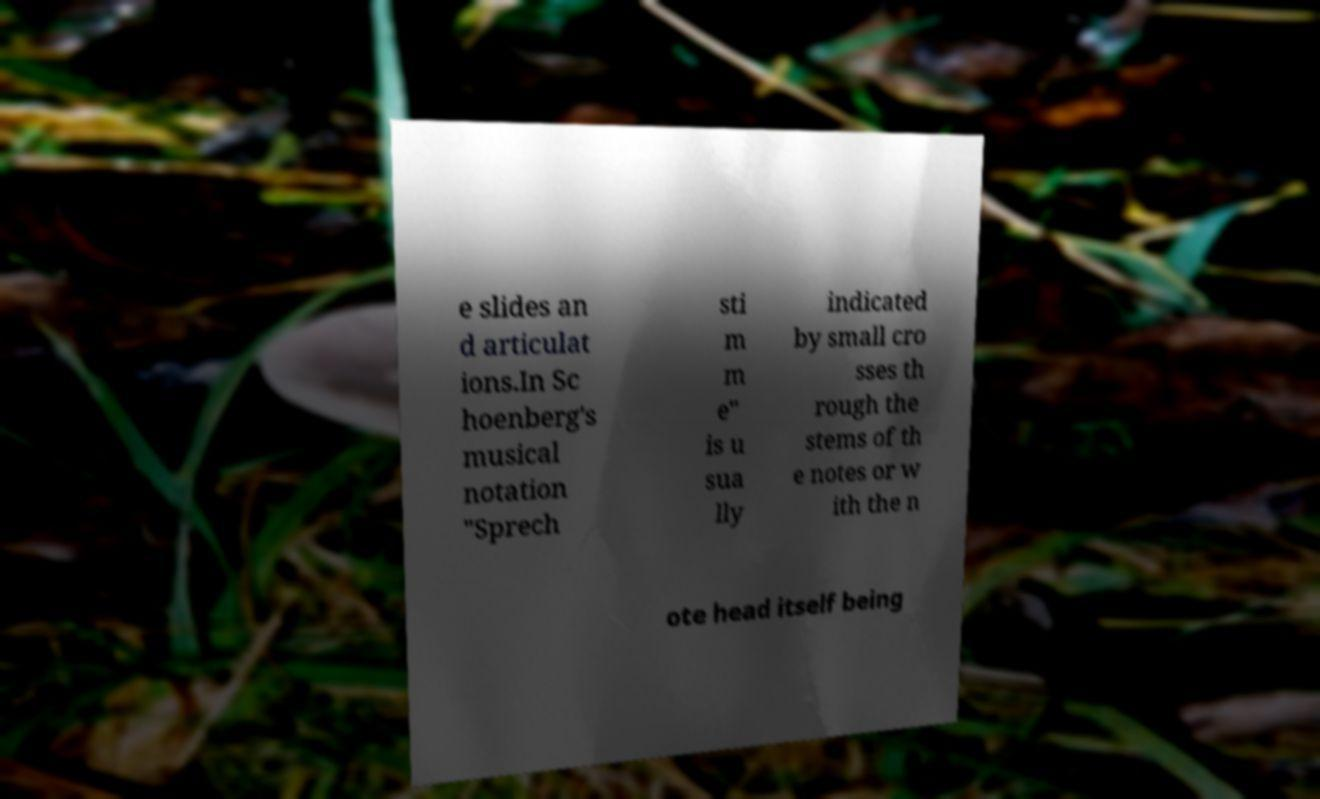There's text embedded in this image that I need extracted. Can you transcribe it verbatim? e slides an d articulat ions.In Sc hoenberg's musical notation "Sprech sti m m e" is u sua lly indicated by small cro sses th rough the stems of th e notes or w ith the n ote head itself being 